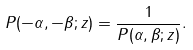Convert formula to latex. <formula><loc_0><loc_0><loc_500><loc_500>P ( - \alpha , - \beta ; z ) = \frac { 1 } { P ( \alpha , \beta ; z ) } .</formula> 